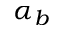<formula> <loc_0><loc_0><loc_500><loc_500>\alpha _ { b }</formula> 